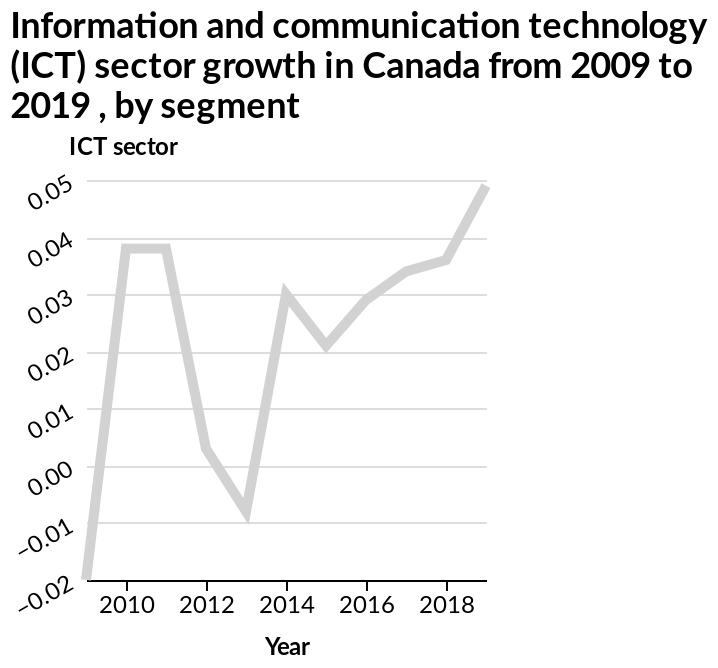<image>
What time period does the line chart cover? The line chart covers the period from 2009 to 2019 for the growth of the Information and communication technology (ICT) sector in Canada, categorized by segment. When did the ICT sector reach its peak growth rate? The ICT sector reached its peak growth rate of 0.05 in 2019. 